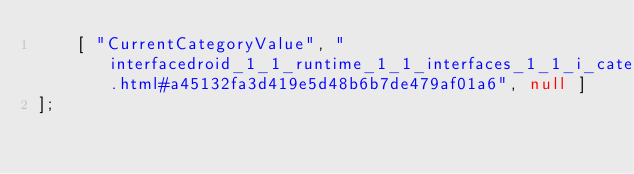Convert code to text. <code><loc_0><loc_0><loc_500><loc_500><_JavaScript_>    [ "CurrentCategoryValue", "interfacedroid_1_1_runtime_1_1_interfaces_1_1_i_category_provider.html#a45132fa3d419e5d48b6b7de479af01a6", null ]
];</code> 